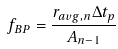<formula> <loc_0><loc_0><loc_500><loc_500>f _ { B P } = \frac { r _ { a v g , n } \Delta t _ { p } } { A _ { n - 1 } }</formula> 